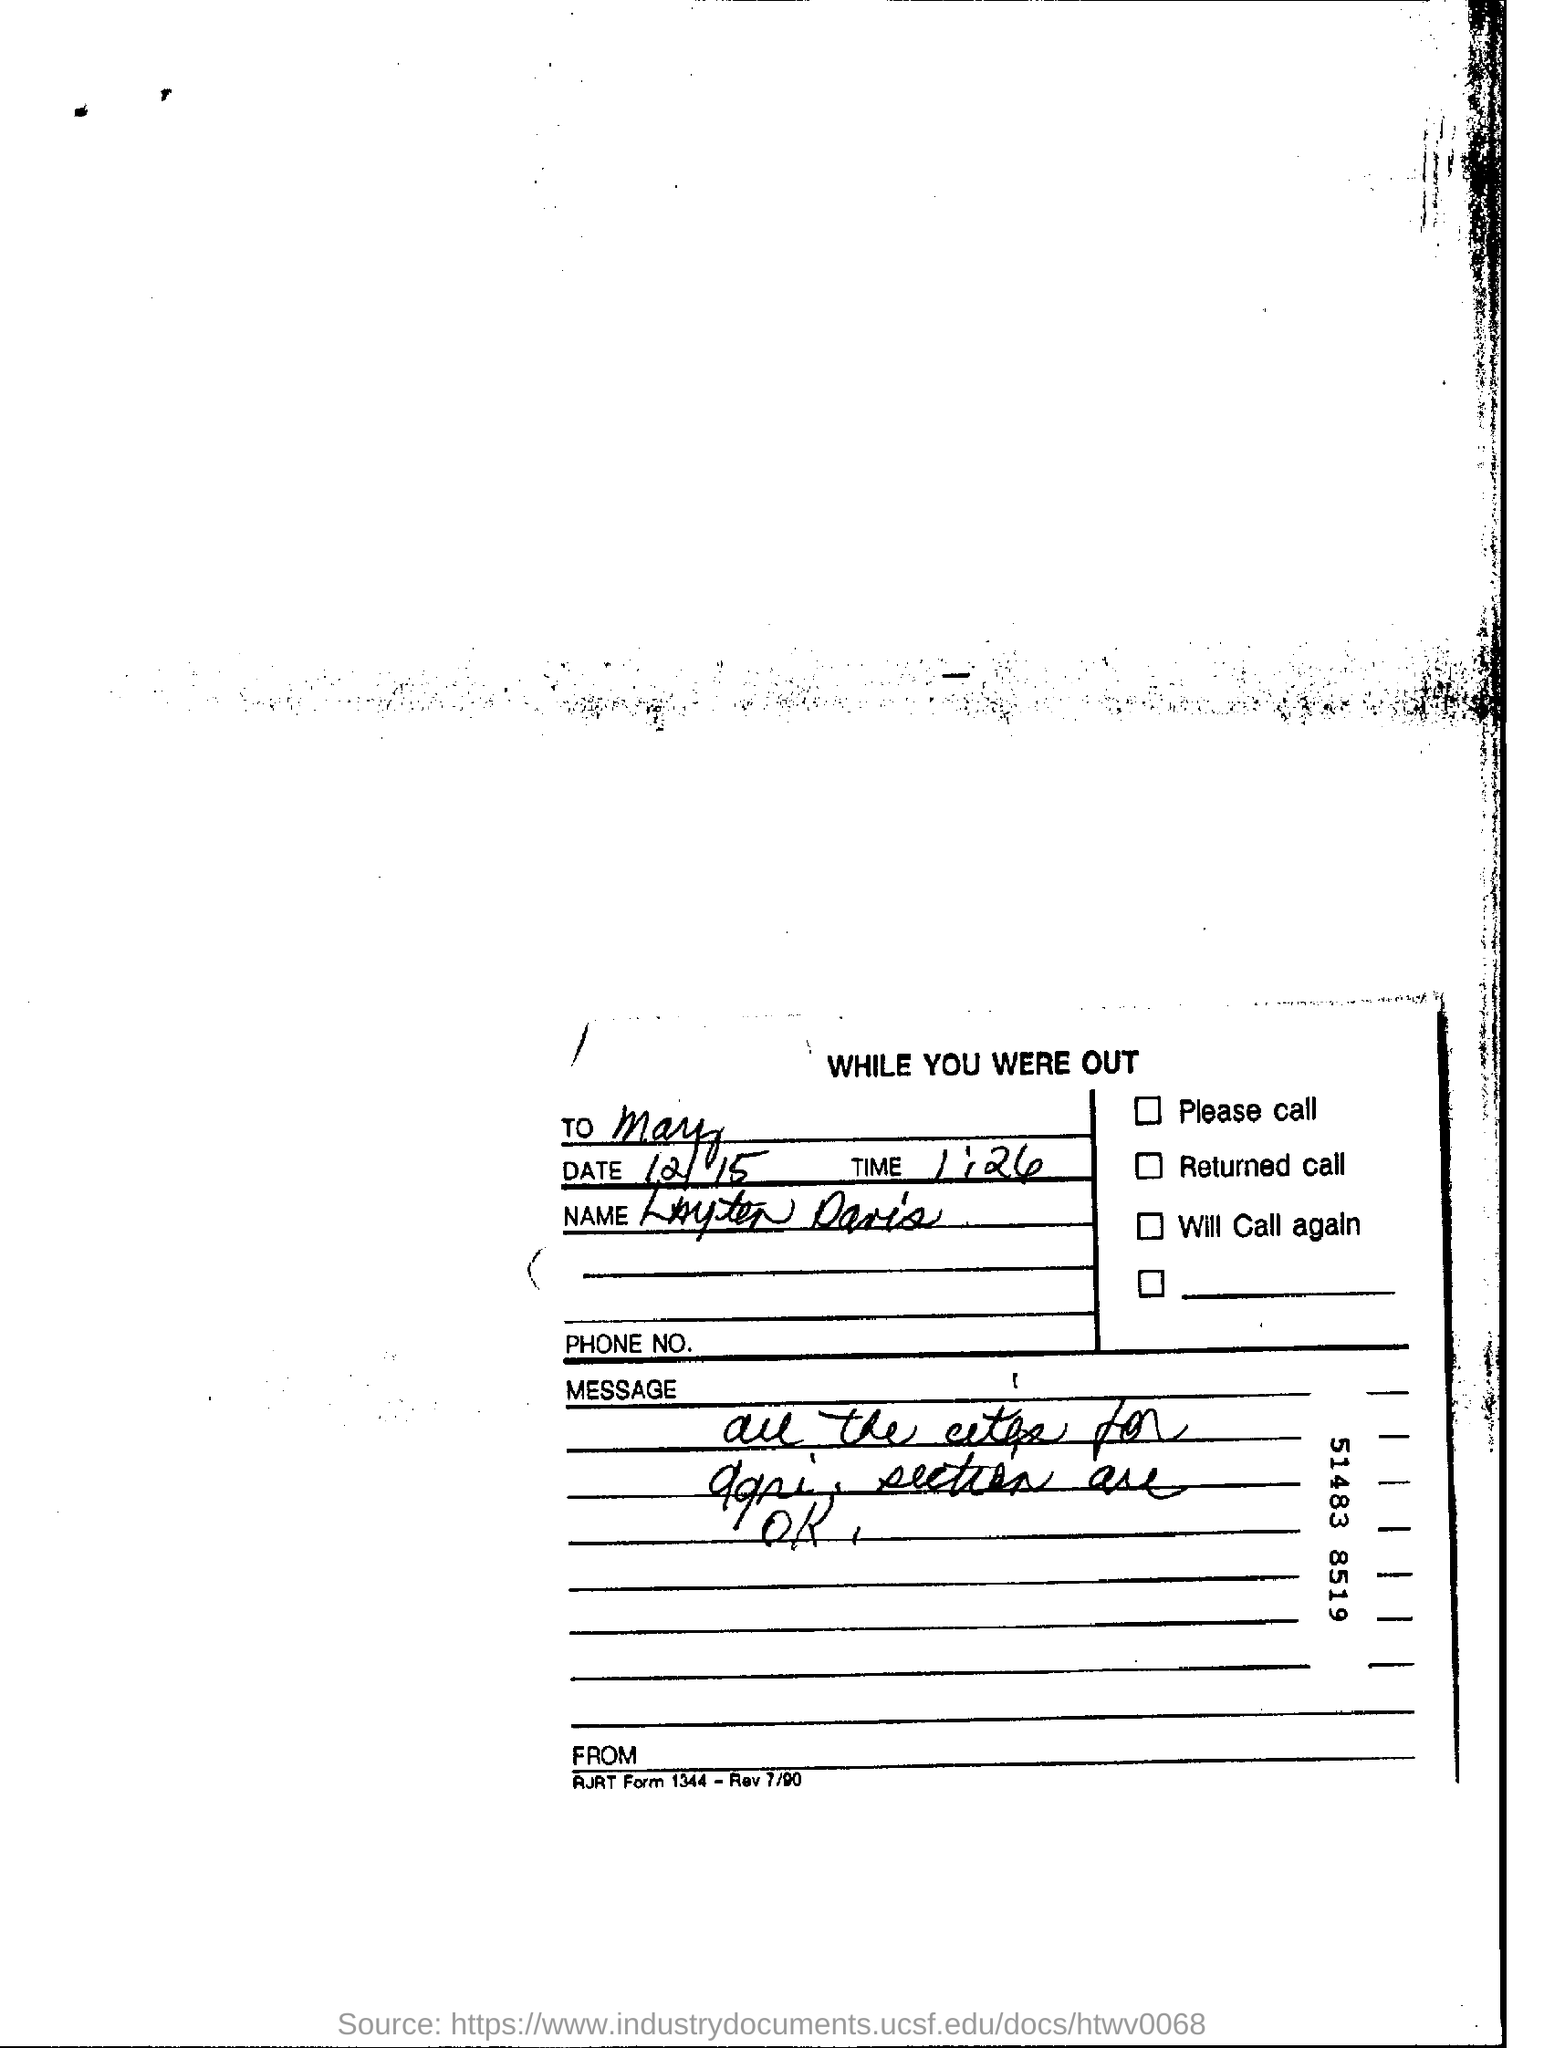What is the heading of the document?
Your answer should be very brief. While you were out. What is the date mentioned?
Provide a short and direct response. 12/15. What is the time mentioned?
Provide a short and direct response. 1:26. 